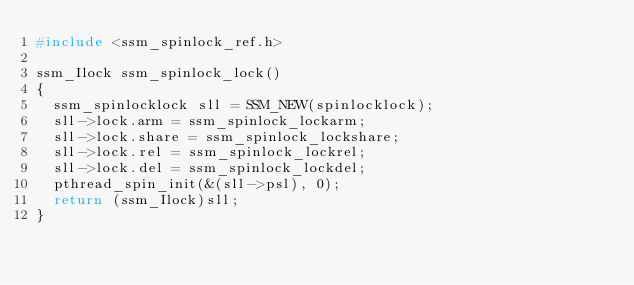<code> <loc_0><loc_0><loc_500><loc_500><_C_>#include <ssm_spinlock_ref.h>

ssm_Ilock ssm_spinlock_lock()
{
  ssm_spinlocklock sll = SSM_NEW(spinlocklock);
  sll->lock.arm = ssm_spinlock_lockarm;
  sll->lock.share = ssm_spinlock_lockshare;
  sll->lock.rel = ssm_spinlock_lockrel;
  sll->lock.del = ssm_spinlock_lockdel;
  pthread_spin_init(&(sll->psl), 0);
  return (ssm_Ilock)sll;
}
</code> 